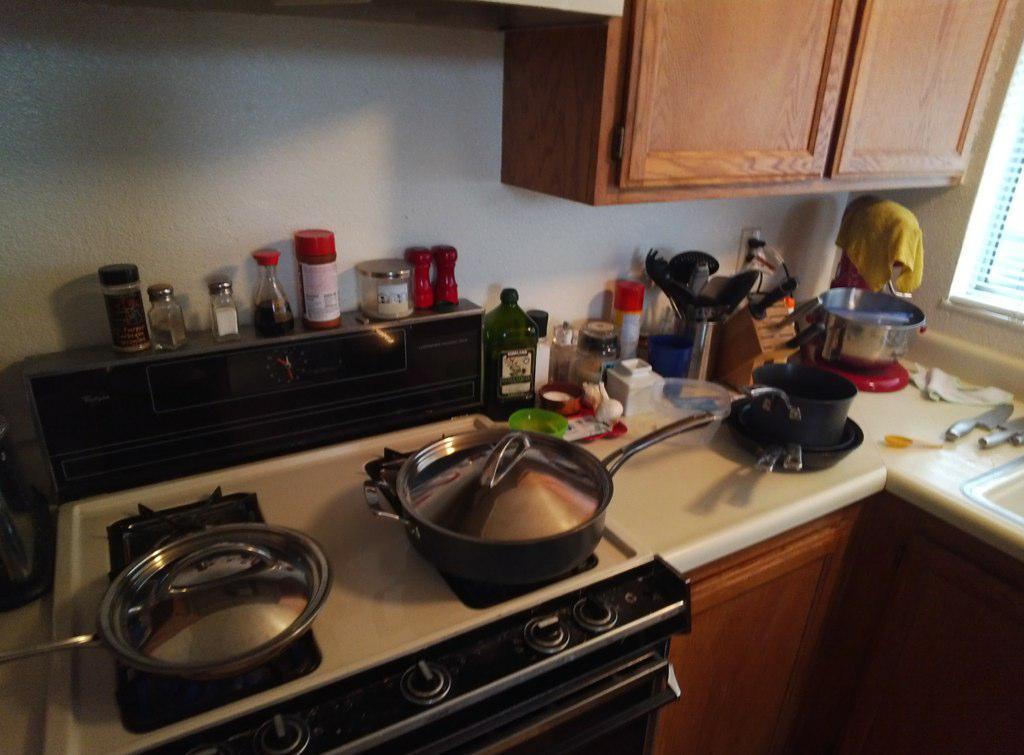Could you give a brief overview of what you see in this image? This image is clicked in the kitchen. There are many things kept on the desk. In the front, we can see a stove along with bowls and a pan. On the right, there is a sink. And we can the knives. At the top, there are cupboards. On the right, there is a window. In the front, there is a wall. 